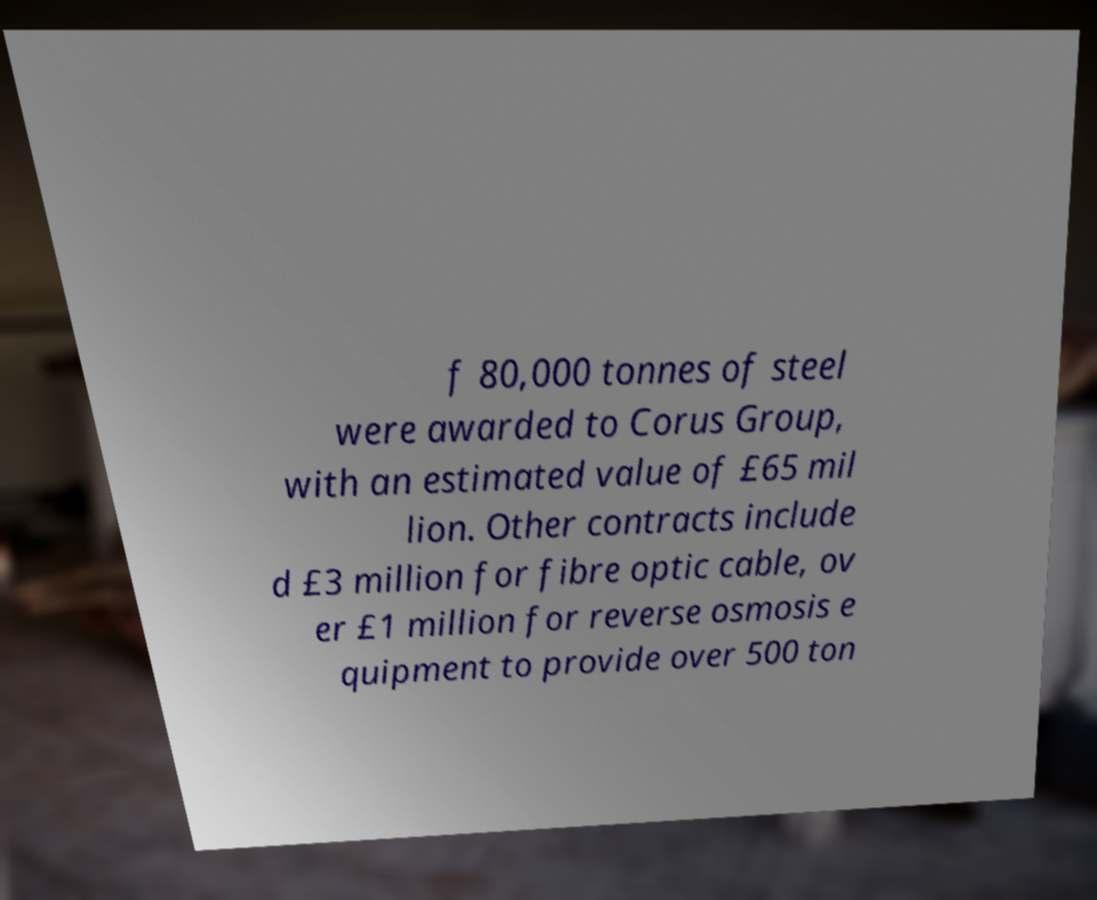For documentation purposes, I need the text within this image transcribed. Could you provide that? f 80,000 tonnes of steel were awarded to Corus Group, with an estimated value of £65 mil lion. Other contracts include d £3 million for fibre optic cable, ov er £1 million for reverse osmosis e quipment to provide over 500 ton 